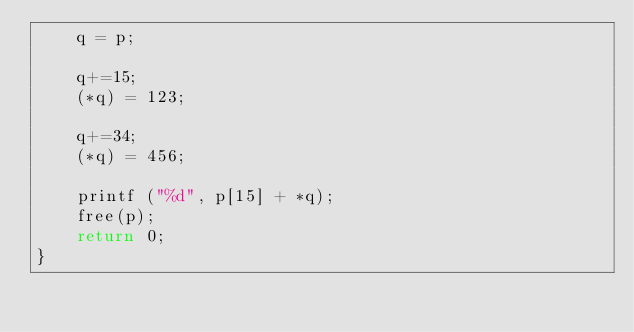Convert code to text. <code><loc_0><loc_0><loc_500><loc_500><_C_>	q = p;

	q+=15;
	(*q) = 123;
	
	q+=34;
	(*q) = 456;
	
	printf ("%d", p[15] + *q);
	free(p);
	return 0;
}
</code> 